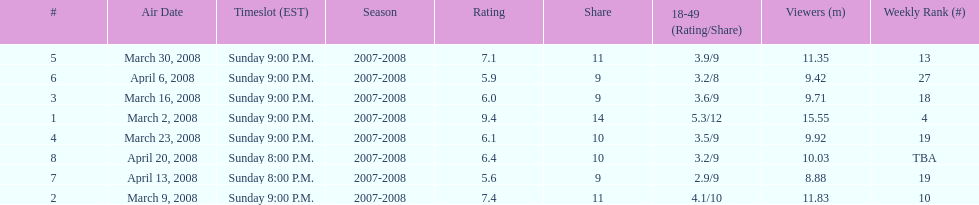The air date with the most viewers March 2, 2008. 